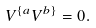<formula> <loc_0><loc_0><loc_500><loc_500>V ^ { \{ a } V ^ { b \} } = 0 .</formula> 